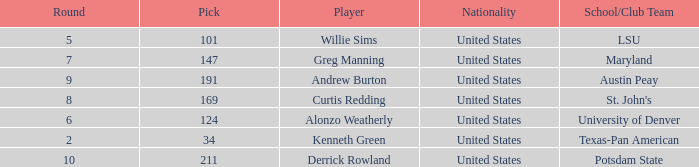What is the average Pick when the round was less than 6 for kenneth green? 34.0. 